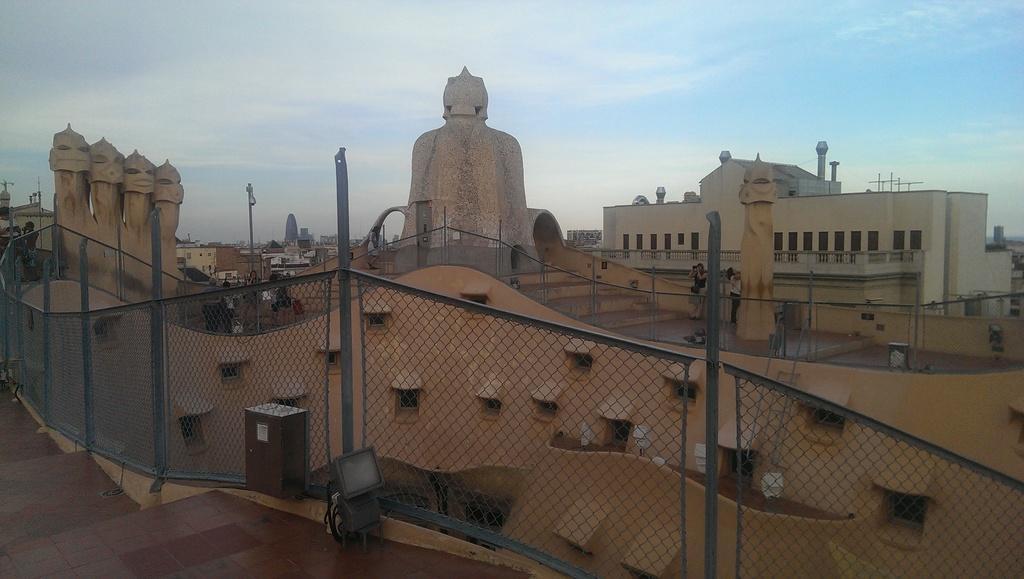Please provide a concise description of this image. This image is taken outdoors. At the bottom of the image there is a floor and there is a railing with a fence. In the background there is an architecture and a few buildings and houses with walls, windows, roofs and doors. At the top of the image there is a sky with clouds. 